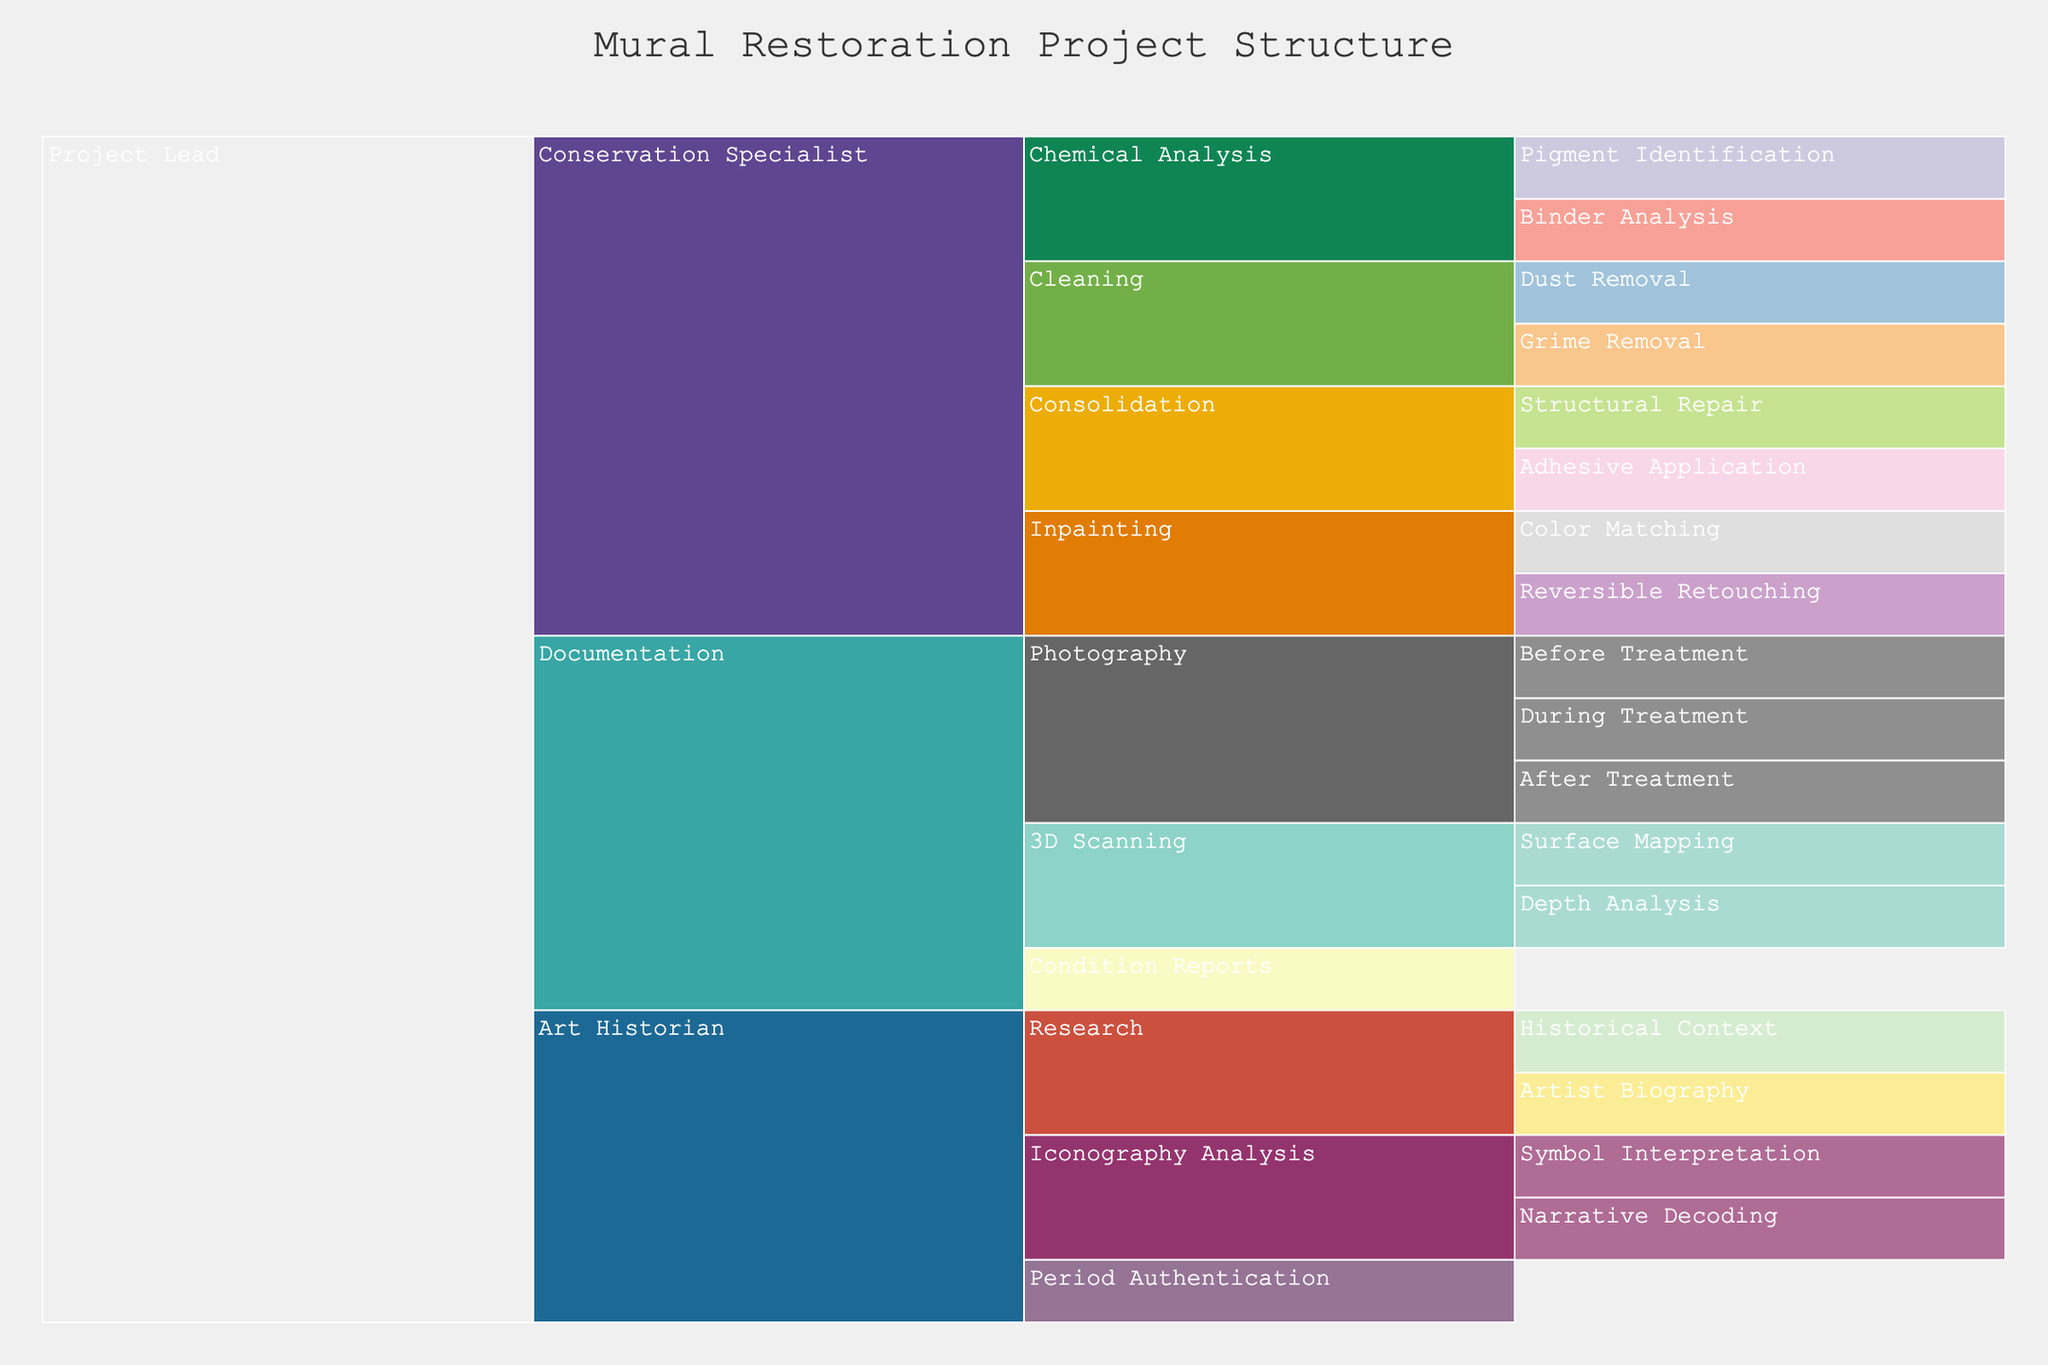what is the title of the figure? The title of the figure is displayed at the top of the chart. Observing carefully, the title reads "Mural Restoration Project Structure".
Answer: "Mural Restoration Project Structure" Which role has the most sub-tasks listed directly under it? To determine this, look at each role's branch and count the number of immediately connected sub-tasks. The role with the highest number of directly linked sub-tasks is "Conservation Specialist", which has four (Chemical Analysis, Cleaning, Consolidation, and Inpainting).
Answer: Conservation Specialist How many roles fall directly under the "Project Lead"? To find this, count the number of immediate branches directly under the "Project Lead". The Project Lead directly oversees four roles (Management, Conservation Specialist, Art Historian, and Documentation).
Answer: Four Which task under "Chemical Analysis" focuses on pigments? Observe the sub-tasks branching from "Chemical Analysis". The task focusing on pigments is "Pigment Identification".
Answer: Pigment Identification What are the three sub-tasks under "3D Scanning"? Examine the branches directly under "3D Scanning". The three sub-tasks are Surface Mapping and Depth Analysis. Two tasks listed.
Answer: Surface Mapping and Depth Analysis Compare the number of sub-tasks under "Photography" and "Cleaning". Which one has more and by how much? Count the sub-tasks under each role. Photography has three sub-tasks (Before Treatment, During Treatment, After Treatment), and Cleaning has two (Dust Removal and Grime Removal). Photography has one more task than Cleaning.
Answer: Photography has one more What level of depth is "Symbol Interpretation" in the hierarchy relative to the "Project Lead"? Trace the path from "Project Lead" to "Symbol Interpretation". The steps are Project Lead -> Art Historian -> Iconography Analysis -> Symbol Interpretation, making it three levels deep from the Project Lead.
Answer: Three levels Which task involves "Reversible Retouching"? Follow the hierarchical branches and tasks under each role. "Reversible Retouching" falls under Inpainting.
Answer: Inpainting Do any roles under the "Art Historian" involve analyzing symbols? If so, which role? Examine the branches under Art Historian. The role associated with analyzing symbols is "Iconography Analysis", which includes "Symbol Interpretation" as a sub-task.
Answer: Iconography Analysis What are the two tasks listed under "Consolidation"? Check the sub-tasks directly related to "Consolidation", which are "Structural Repair" and "Adhesive Application".
Answer: Structural Repair and Adhesive Application 